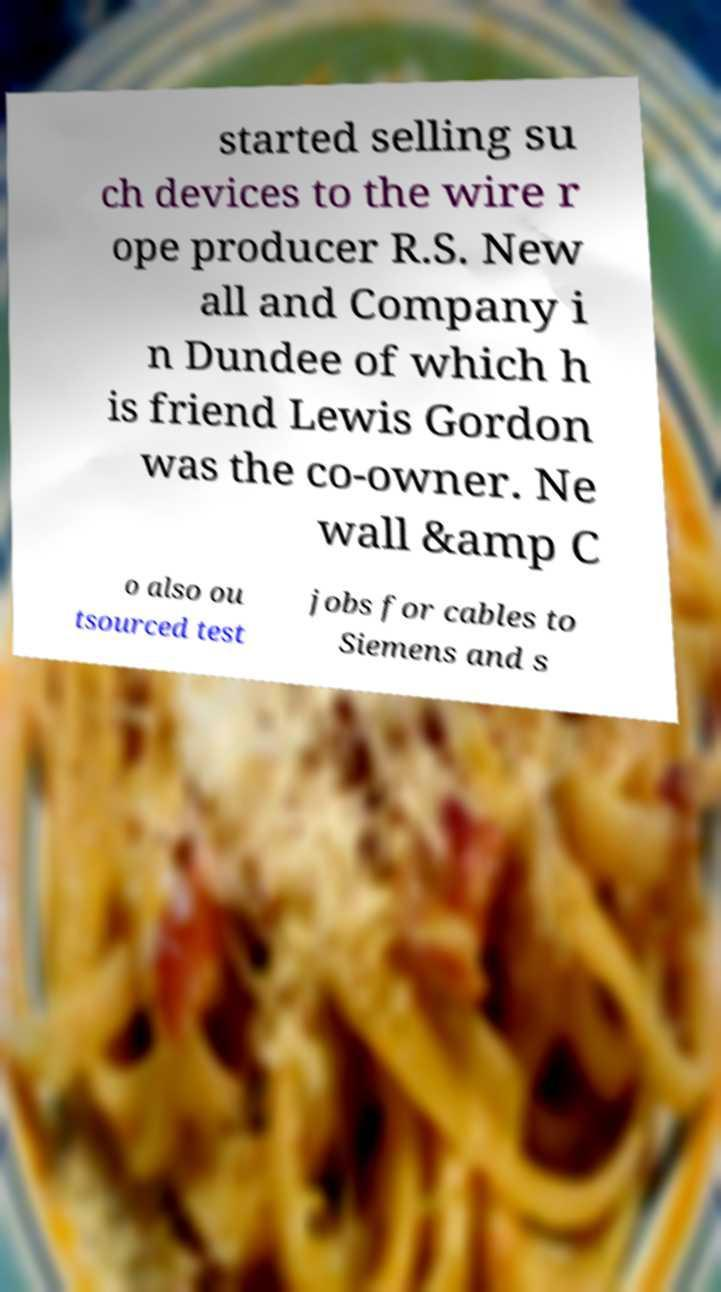What messages or text are displayed in this image? I need them in a readable, typed format. started selling su ch devices to the wire r ope producer R.S. New all and Company i n Dundee of which h is friend Lewis Gordon was the co-owner. Ne wall &amp C o also ou tsourced test jobs for cables to Siemens and s 